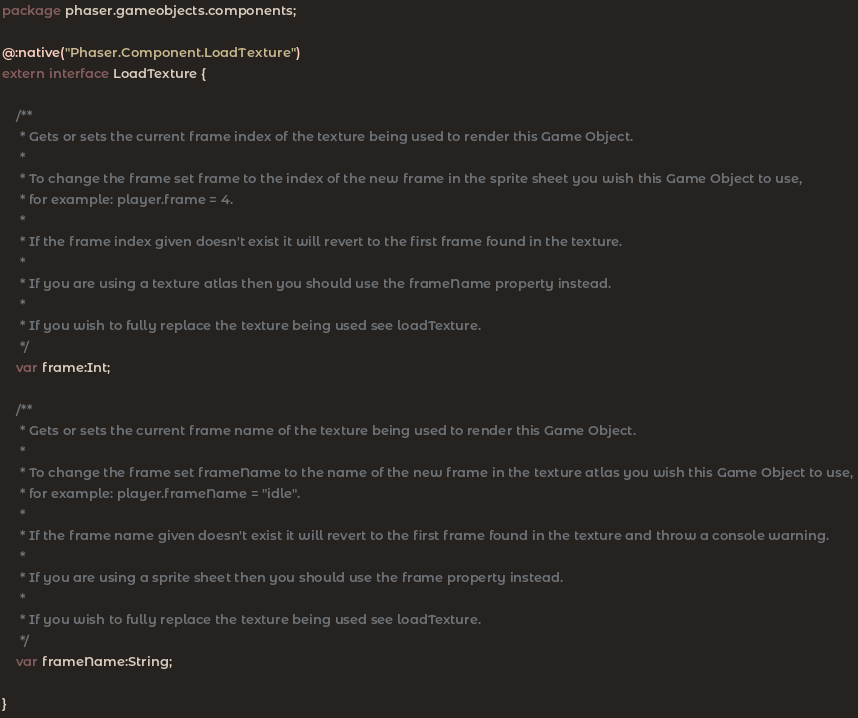Convert code to text. <code><loc_0><loc_0><loc_500><loc_500><_Haxe_>package phaser.gameobjects.components;

@:native("Phaser.Component.LoadTexture")
extern interface LoadTexture {
	
	/**
	 * Gets or sets the current frame index of the texture being used to render this Game Object.
	 * 
	 * To change the frame set frame to the index of the new frame in the sprite sheet you wish this Game Object to use,
	 * for example: player.frame = 4.
	 * 
	 * If the frame index given doesn't exist it will revert to the first frame found in the texture.
	 * 
	 * If you are using a texture atlas then you should use the frameName property instead.
	 * 
	 * If you wish to fully replace the texture being used see loadTexture.
	 */
	var frame:Int;
	
	/**
	 * Gets or sets the current frame name of the texture being used to render this Game Object.
	 * 
	 * To change the frame set frameName to the name of the new frame in the texture atlas you wish this Game Object to use, 
	 * for example: player.frameName = "idle".
	 * 
	 * If the frame name given doesn't exist it will revert to the first frame found in the texture and throw a console warning.
	 * 
	 * If you are using a sprite sheet then you should use the frame property instead.
	 * 
	 * If you wish to fully replace the texture being used see loadTexture.
	 */
	var frameName:String;
	
}
</code> 